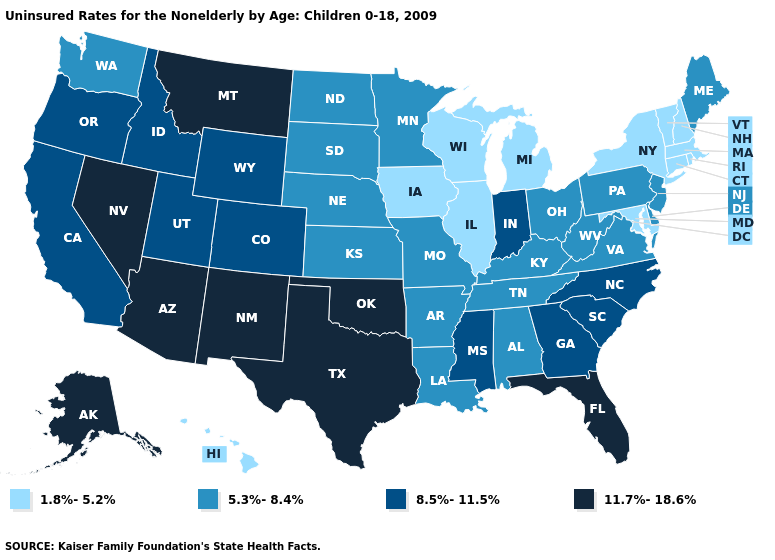Among the states that border California , which have the lowest value?
Be succinct. Oregon. Name the states that have a value in the range 11.7%-18.6%?
Short answer required. Alaska, Arizona, Florida, Montana, Nevada, New Mexico, Oklahoma, Texas. Name the states that have a value in the range 11.7%-18.6%?
Give a very brief answer. Alaska, Arizona, Florida, Montana, Nevada, New Mexico, Oklahoma, Texas. What is the highest value in the USA?
Give a very brief answer. 11.7%-18.6%. Name the states that have a value in the range 11.7%-18.6%?
Write a very short answer. Alaska, Arizona, Florida, Montana, Nevada, New Mexico, Oklahoma, Texas. Does Maryland have the highest value in the USA?
Quick response, please. No. Does New Mexico have a higher value than Idaho?
Short answer required. Yes. Name the states that have a value in the range 5.3%-8.4%?
Quick response, please. Alabama, Arkansas, Delaware, Kansas, Kentucky, Louisiana, Maine, Minnesota, Missouri, Nebraska, New Jersey, North Dakota, Ohio, Pennsylvania, South Dakota, Tennessee, Virginia, Washington, West Virginia. Which states have the lowest value in the USA?
Keep it brief. Connecticut, Hawaii, Illinois, Iowa, Maryland, Massachusetts, Michigan, New Hampshire, New York, Rhode Island, Vermont, Wisconsin. What is the value of Arizona?
Keep it brief. 11.7%-18.6%. Name the states that have a value in the range 5.3%-8.4%?
Give a very brief answer. Alabama, Arkansas, Delaware, Kansas, Kentucky, Louisiana, Maine, Minnesota, Missouri, Nebraska, New Jersey, North Dakota, Ohio, Pennsylvania, South Dakota, Tennessee, Virginia, Washington, West Virginia. Which states have the lowest value in the USA?
Concise answer only. Connecticut, Hawaii, Illinois, Iowa, Maryland, Massachusetts, Michigan, New Hampshire, New York, Rhode Island, Vermont, Wisconsin. What is the value of Texas?
Short answer required. 11.7%-18.6%. Does Idaho have the same value as Iowa?
Keep it brief. No. Does Georgia have a higher value than Hawaii?
Quick response, please. Yes. 